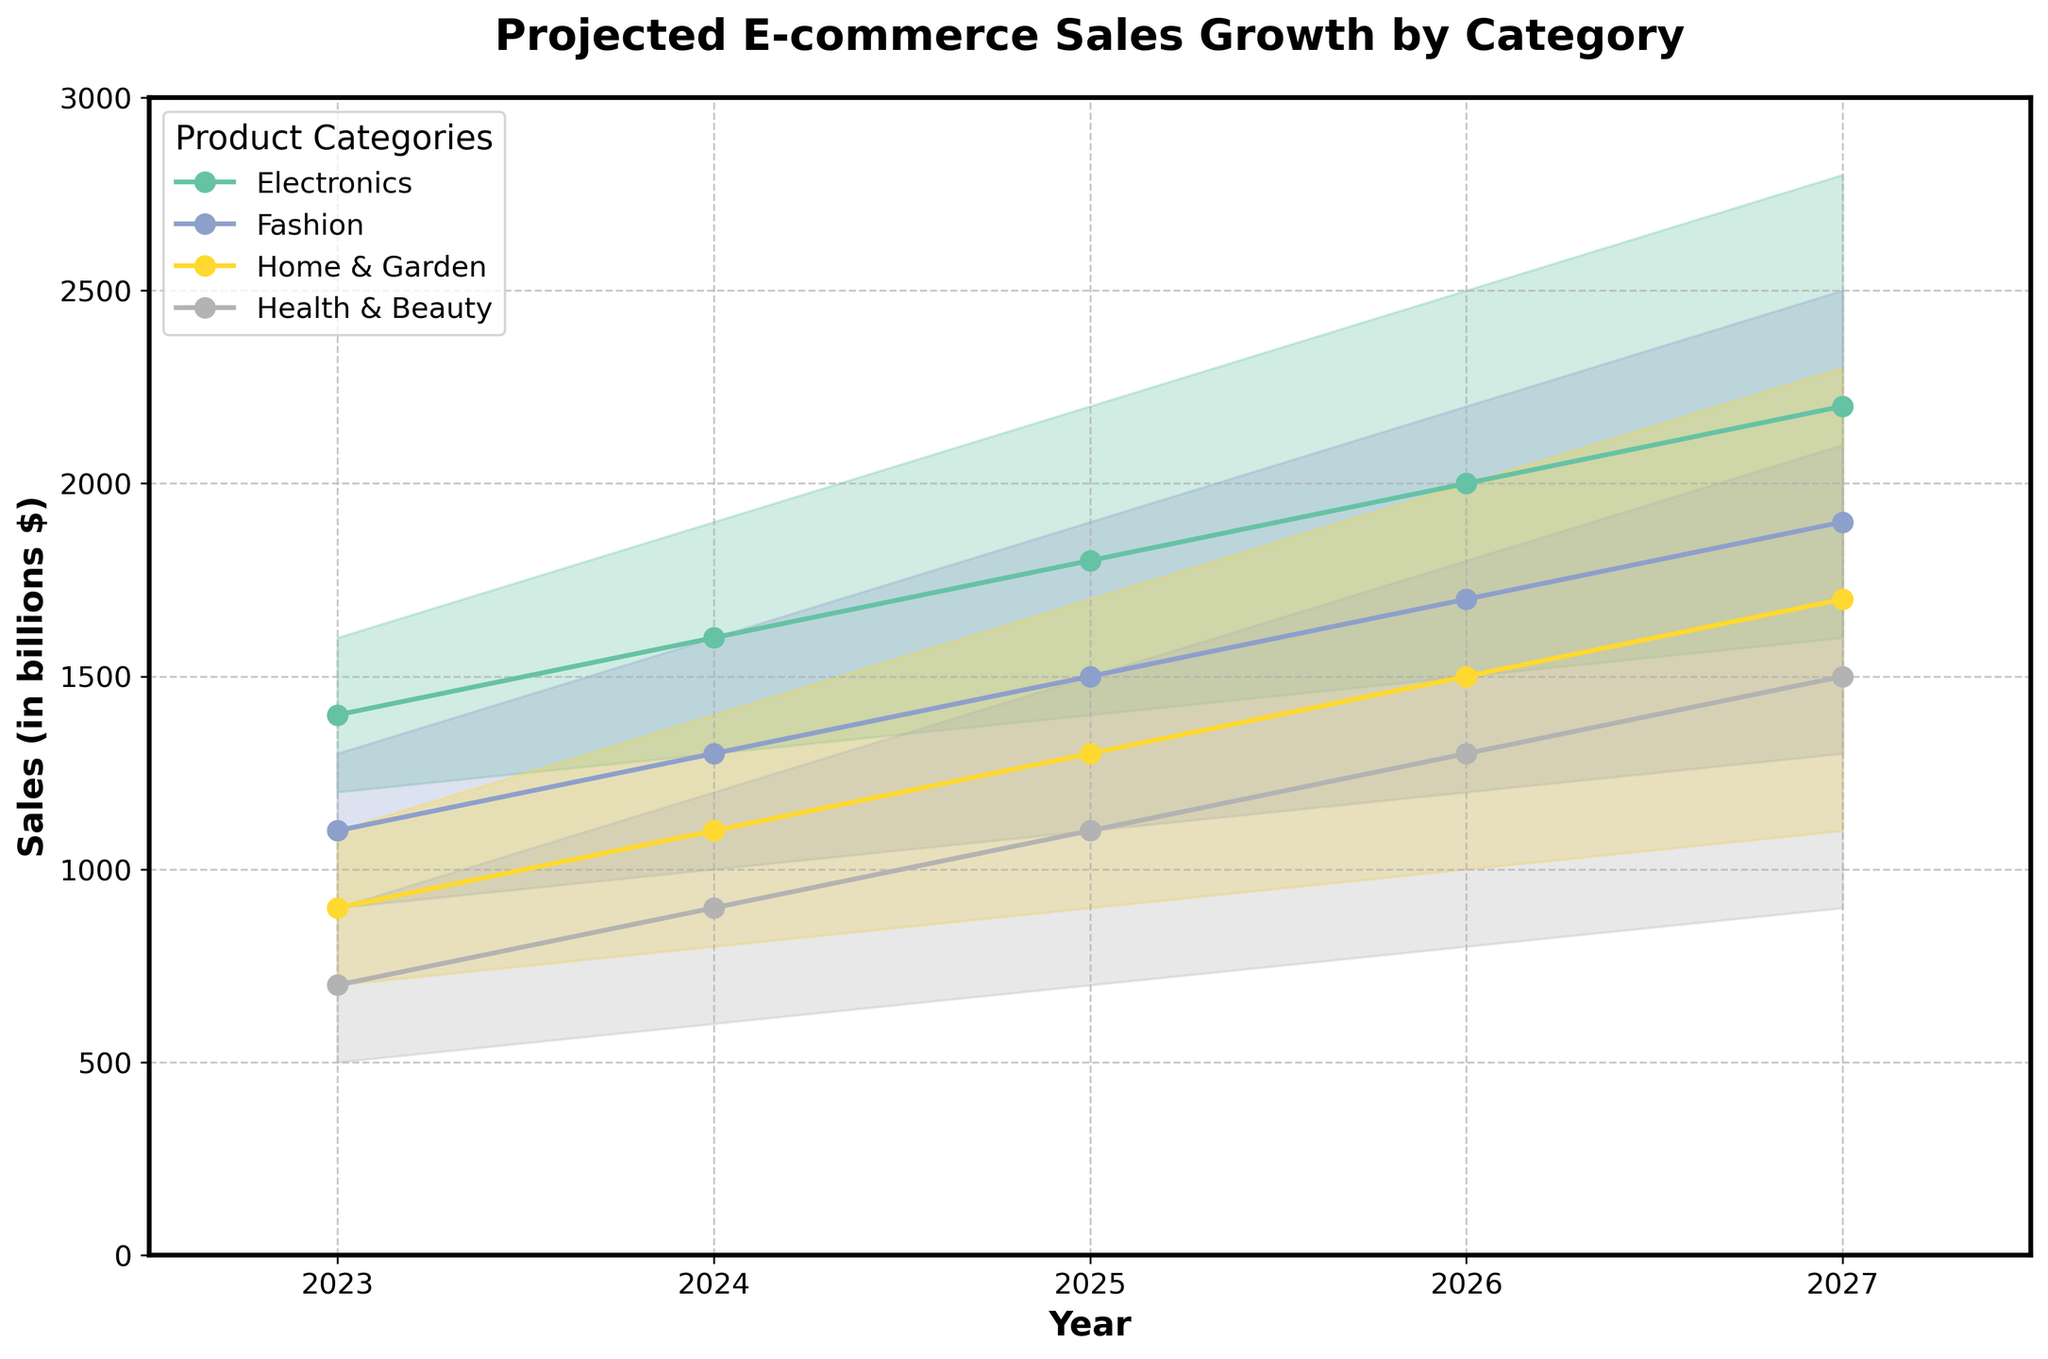What is the projected sales for Electronics in 2025? Look at the line for the "Electronics" category and locate the value corresponding to the year 2025. The midpoint value is the median projected sales.
Answer: 1800 Which category had the lowest projected sales in 2023 at the mid level? Compare the mid-level values for each category in 2023. The category with the smallest value represents the lowest projected sales.
Answer: Health & Beauty What is the difference in projected high sales for Fashion between 2026 and 2027? Locate the high projection values for Fashion in 2026 and 2027. Subtract the value for 2026 from the value for 2027 to find the difference.
Answer: 300 Which category shows a projected increase in sales each year from 2023 to 2027? Check the mid values for each category year by year. Identify the category (or categories) that consistently show increasing values over the years.
Answer: All categories What is the range of projected sales for Home & Garden in 2024? Find the minimum (low) and maximum (high) projected sales for Home & Garden in 2024. Subtract the low value from the high value to calculate the range.
Answer: 600 For which year does Electronics have the highest projected midpoint sales? Compare the mid values for the Electronics category across the years 2023 to 2027. Identify the year with the highest midpoint value.
Answer: 2027 By how much is the projected midpoint sales for Health & Beauty expected to grow from 2023 to 2025? Note the mid values for Health & Beauty in 2023 and 2025. Subtract the 2023 value from the 2025 value to find the growth amount.
Answer: 400 Which category has the narrowest projection interval for 2023? Evaluate the difference between high and low values for each category in 2023. The category with the smallest difference has the narrowest projection interval.
Answer: Health & Beauty What year is expected to have the largest total midpoint sales across all categories? Sum the mid values of all categories for each year from 2023 to 2027. Compare these sums to find which year has the largest total midpoint sales.
Answer: 2027 How does the midpoint value for Fashion in 2025 compare to Electronics in the same year? Identify the mid values for both Fashion and Electronics in 2025. Compare these values to determine which is higher.
Answer: Electronics is higher 